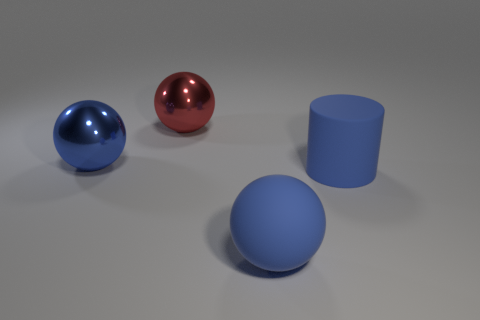Is the color of the matte sphere the same as the matte thing that is behind the rubber sphere?
Offer a very short reply. Yes. There is a red sphere that is the same size as the blue metallic sphere; what is its material?
Your answer should be very brief. Metal. Are there any objects that have the same material as the cylinder?
Your answer should be compact. Yes. What number of balls are there?
Offer a very short reply. 3. Do the large red sphere and the object left of the red metal object have the same material?
Give a very brief answer. Yes. There is another sphere that is the same color as the big rubber sphere; what is its material?
Provide a succinct answer. Metal. How many big metal things are the same color as the big rubber cylinder?
Offer a very short reply. 1. What size is the blue matte ball?
Your answer should be compact. Large. Does the large red metallic thing have the same shape as the large blue rubber thing in front of the big blue matte cylinder?
Give a very brief answer. Yes. What color is the other large sphere that is the same material as the big red sphere?
Keep it short and to the point. Blue. 